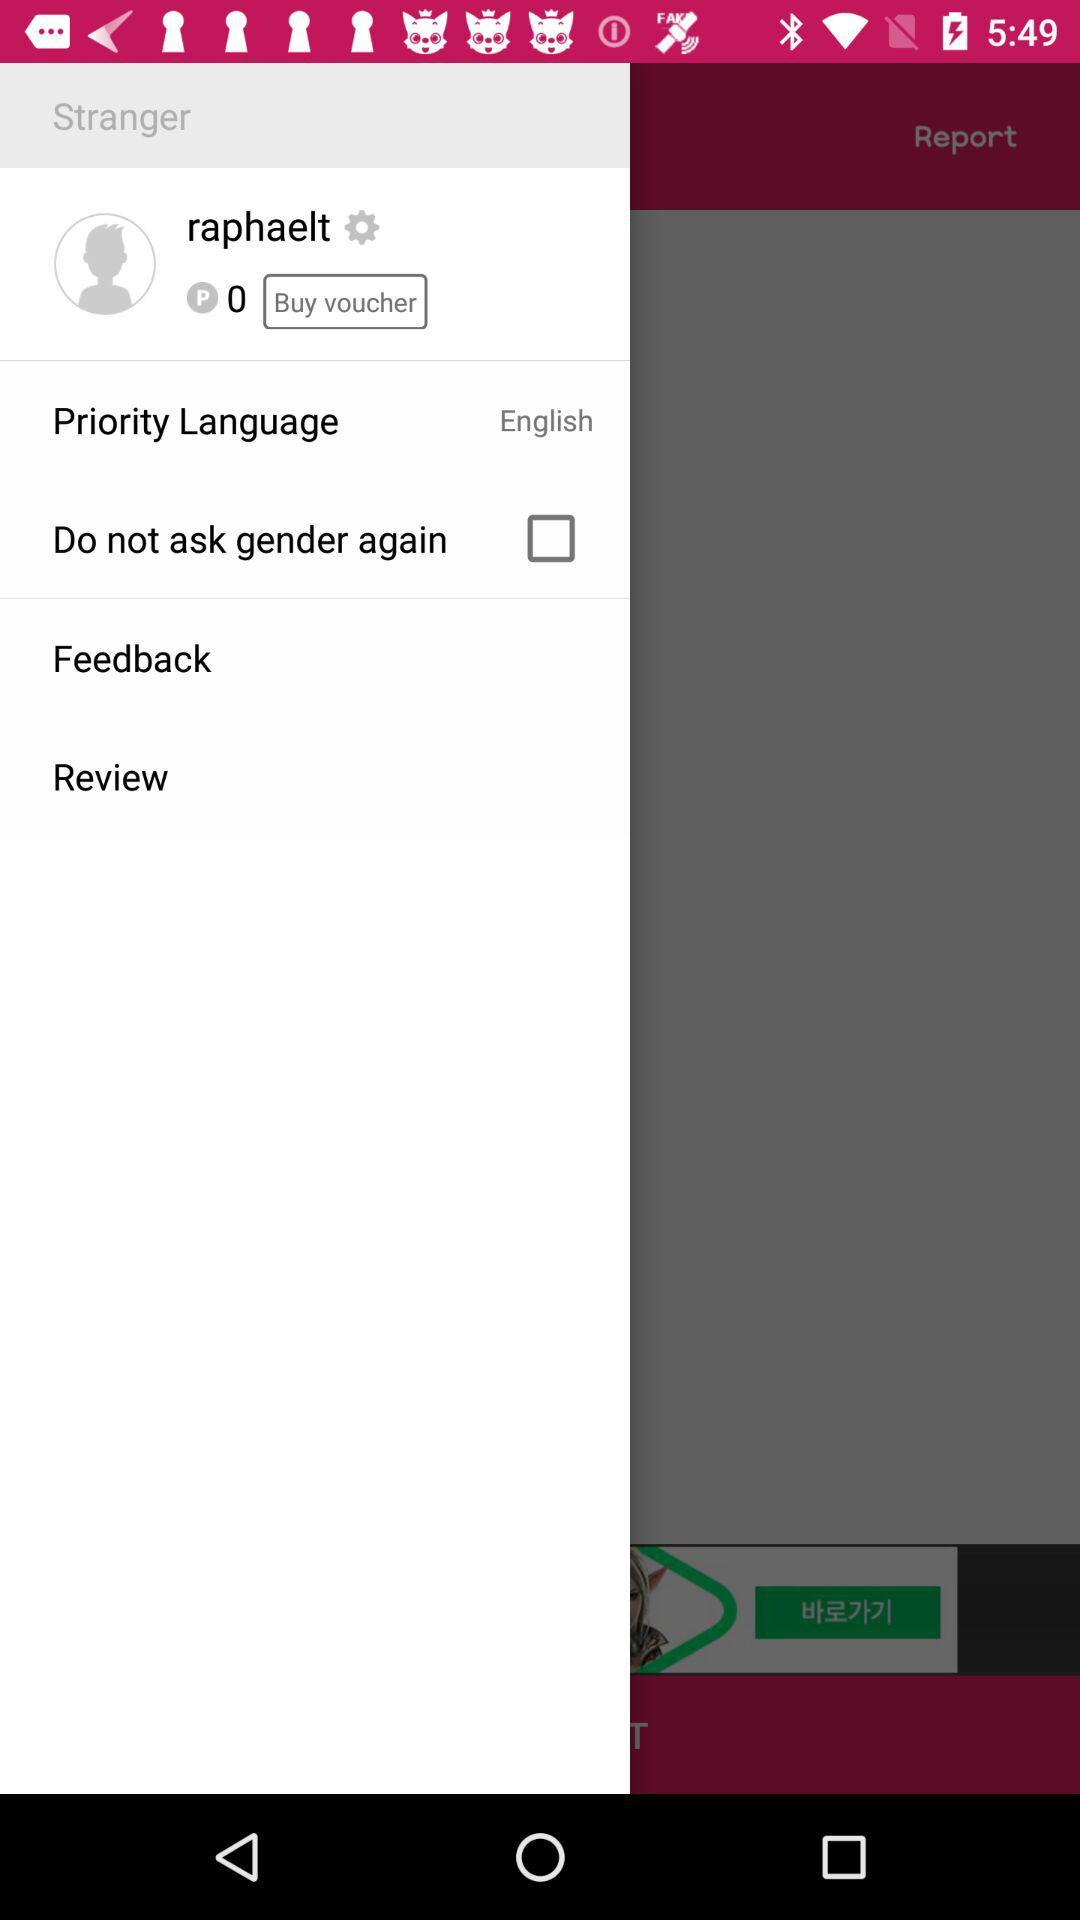How many points are there? There are 0 points. 